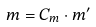<formula> <loc_0><loc_0><loc_500><loc_500>m = C _ { m } \cdot m ^ { \prime }</formula> 